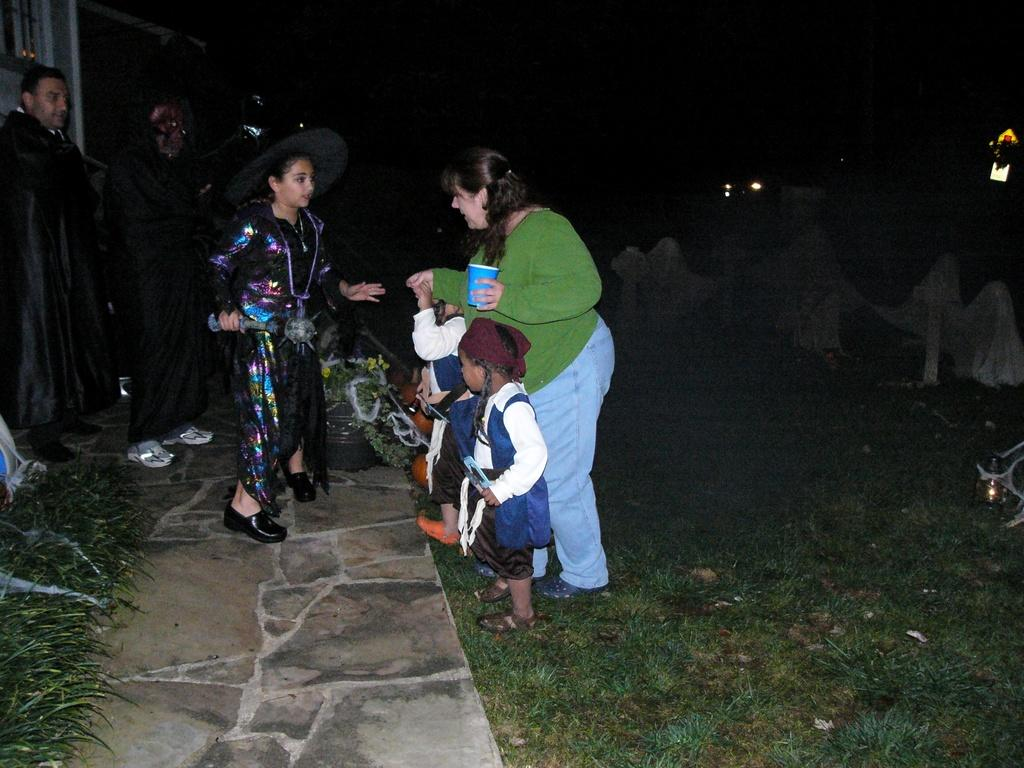What is the main subject of the image? The main subject of the image is the persons in the middle of the image. Can you describe the people in the image? Yes, there are girls, women, and men in the image. What is the ground made of in the image? The ground is made of grass, as it is visible at the bottom of the image. What type of lettuce can be seen growing in the image? There is no lettuce present in the image; it features grass at the bottom. How do the people in the image join together to form a single entity? The people in the image are not joining together to form a single entity; they are separate individuals. 